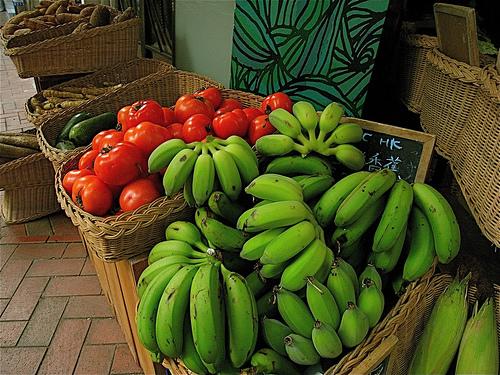Where are the bananas?
Keep it brief. Basket. What is the green fruit?
Give a very brief answer. Bananas. What containers are holding the food?
Answer briefly. Baskets. What kind of fruit is in the picture?
Concise answer only. Bananas. Are the bananas ripe?
Keep it brief. No. 